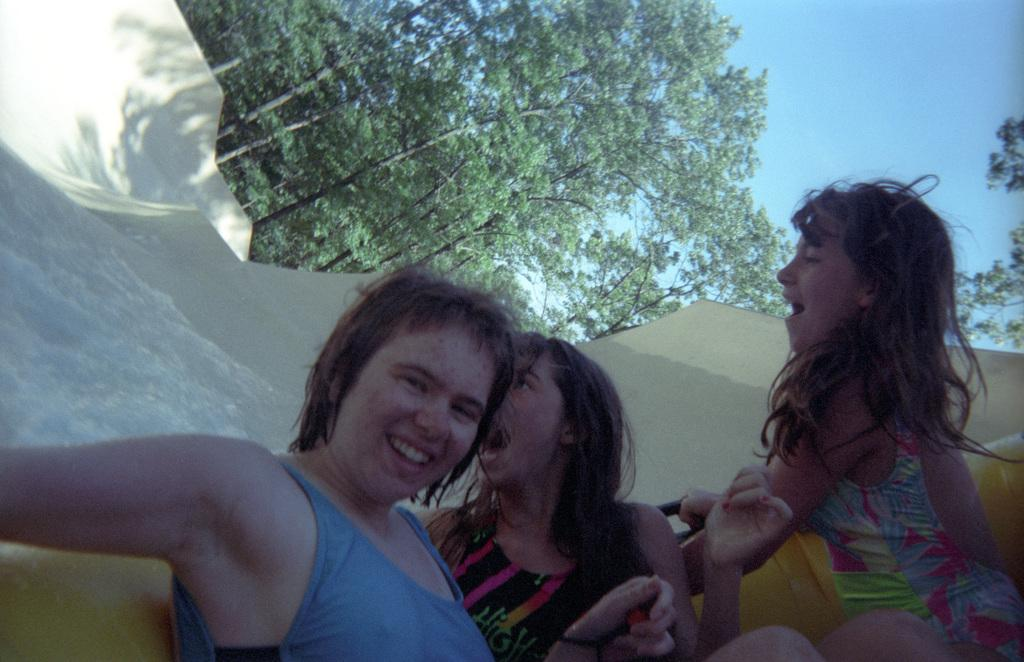Who or what is present in the image? There are people in the image. What is the facial expression of the people in the image? The people are smiling. What can be seen in the background of the image? There are trees and a slope in the background of the image. What is visible at the top of the image? The sky is visible at the top of the image. How much wealth is depicted in the image? There is no indication of wealth in the image; it features people smiling with trees and a slope in the background. What type of sand can be seen on the slope in the image? There is no sand visible in the image; it features a slope with trees in the background. 